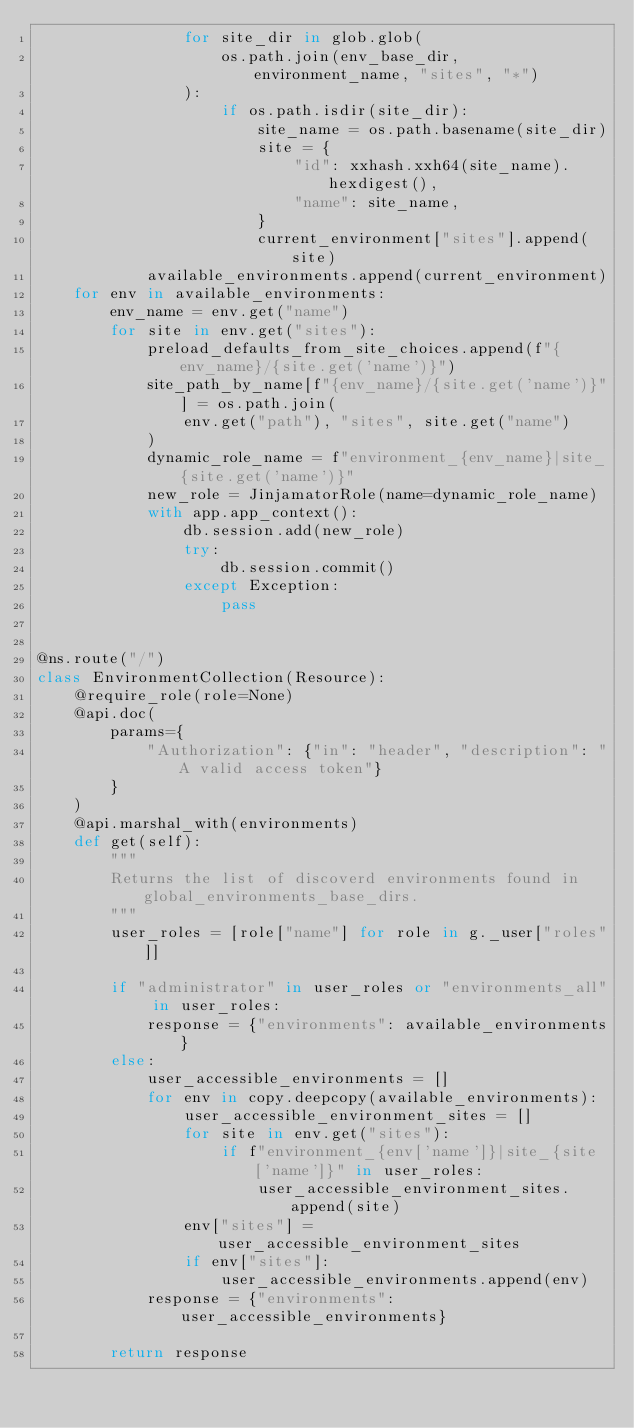<code> <loc_0><loc_0><loc_500><loc_500><_Python_>                for site_dir in glob.glob(
                    os.path.join(env_base_dir, environment_name, "sites", "*")
                ):
                    if os.path.isdir(site_dir):
                        site_name = os.path.basename(site_dir)
                        site = {
                            "id": xxhash.xxh64(site_name).hexdigest(),
                            "name": site_name,
                        }
                        current_environment["sites"].append(site)
            available_environments.append(current_environment)
    for env in available_environments:
        env_name = env.get("name")
        for site in env.get("sites"):
            preload_defaults_from_site_choices.append(f"{env_name}/{site.get('name')}")
            site_path_by_name[f"{env_name}/{site.get('name')}"] = os.path.join(
                env.get("path"), "sites", site.get("name")
            )
            dynamic_role_name = f"environment_{env_name}|site_{site.get('name')}"
            new_role = JinjamatorRole(name=dynamic_role_name)
            with app.app_context():
                db.session.add(new_role)
                try:
                    db.session.commit()
                except Exception:
                    pass


@ns.route("/")
class EnvironmentCollection(Resource):
    @require_role(role=None)
    @api.doc(
        params={
            "Authorization": {"in": "header", "description": "A valid access token"}
        }
    )
    @api.marshal_with(environments)
    def get(self):
        """
        Returns the list of discoverd environments found in global_environments_base_dirs.
        """
        user_roles = [role["name"] for role in g._user["roles"]]

        if "administrator" in user_roles or "environments_all" in user_roles:
            response = {"environments": available_environments}
        else:
            user_accessible_environments = []
            for env in copy.deepcopy(available_environments):
                user_accessible_environment_sites = []
                for site in env.get("sites"):
                    if f"environment_{env['name']}|site_{site['name']}" in user_roles:
                        user_accessible_environment_sites.append(site)
                env["sites"] = user_accessible_environment_sites
                if env["sites"]:
                    user_accessible_environments.append(env)
            response = {"environments": user_accessible_environments}

        return response
</code> 